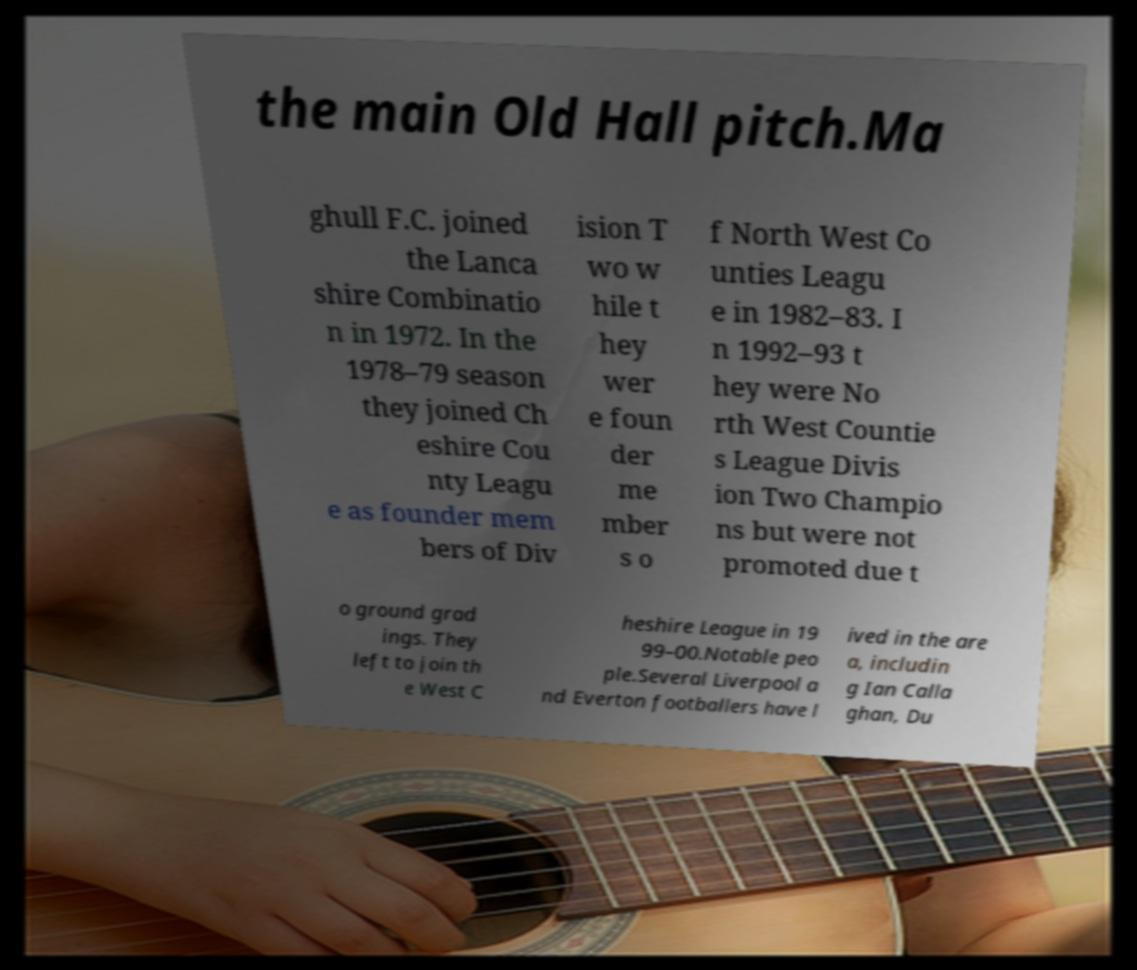Can you read and provide the text displayed in the image?This photo seems to have some interesting text. Can you extract and type it out for me? the main Old Hall pitch.Ma ghull F.C. joined the Lanca shire Combinatio n in 1972. In the 1978–79 season they joined Ch eshire Cou nty Leagu e as founder mem bers of Div ision T wo w hile t hey wer e foun der me mber s o f North West Co unties Leagu e in 1982–83. I n 1992–93 t hey were No rth West Countie s League Divis ion Two Champio ns but were not promoted due t o ground grad ings. They left to join th e West C heshire League in 19 99–00.Notable peo ple.Several Liverpool a nd Everton footballers have l ived in the are a, includin g Ian Calla ghan, Du 